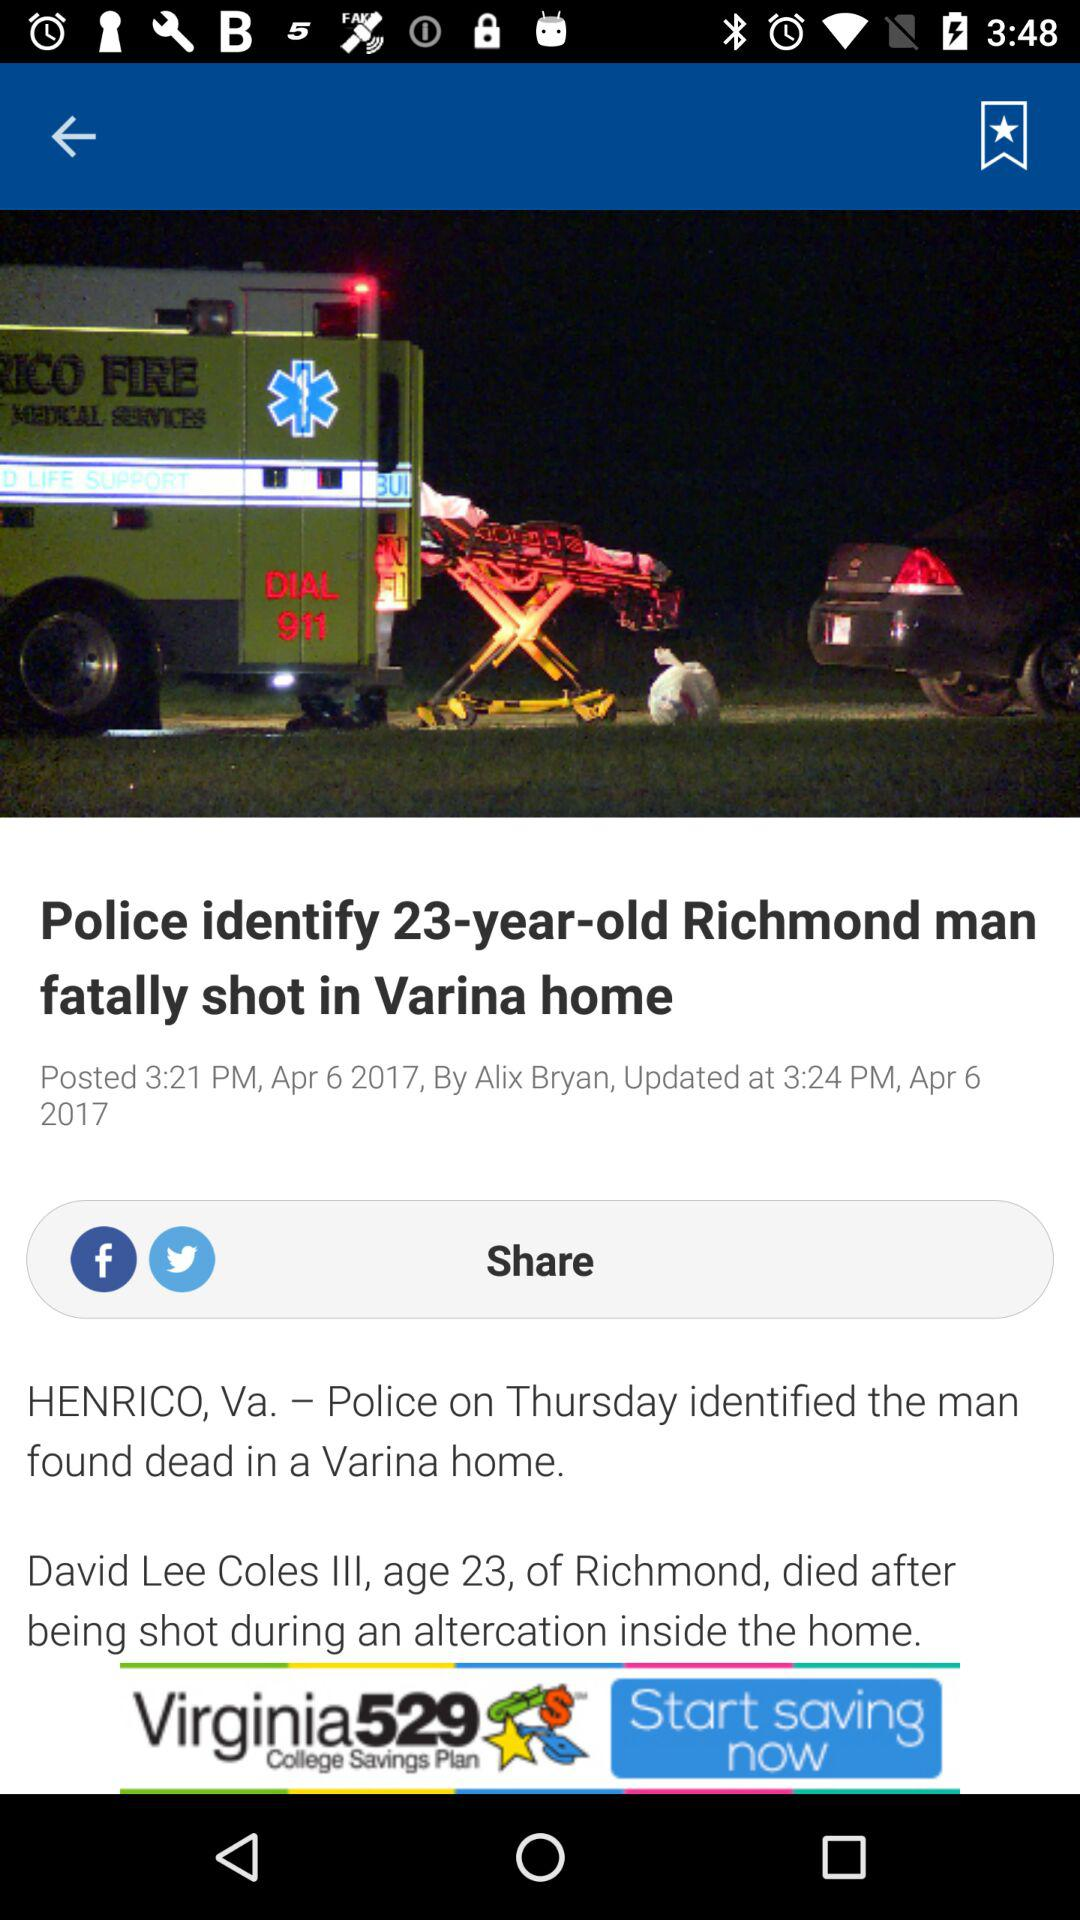How many minutes after the article was posted was it updated?
Answer the question using a single word or phrase. 3 